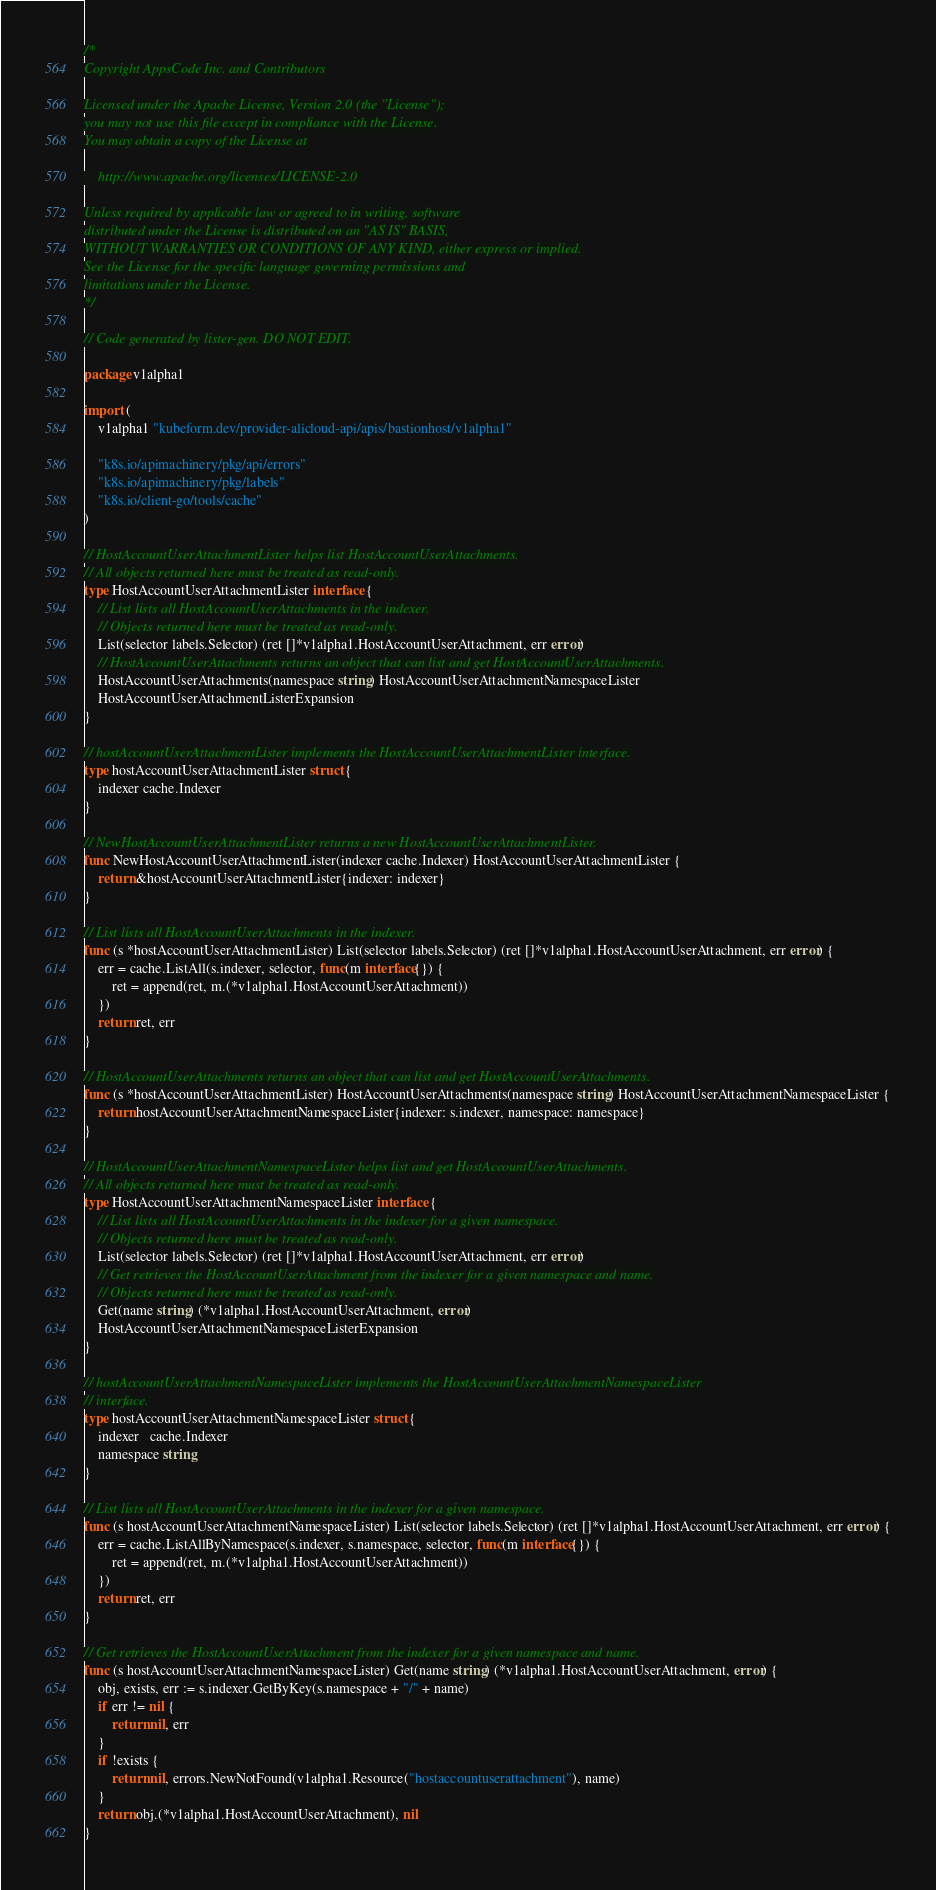Convert code to text. <code><loc_0><loc_0><loc_500><loc_500><_Go_>/*
Copyright AppsCode Inc. and Contributors

Licensed under the Apache License, Version 2.0 (the "License");
you may not use this file except in compliance with the License.
You may obtain a copy of the License at

    http://www.apache.org/licenses/LICENSE-2.0

Unless required by applicable law or agreed to in writing, software
distributed under the License is distributed on an "AS IS" BASIS,
WITHOUT WARRANTIES OR CONDITIONS OF ANY KIND, either express or implied.
See the License for the specific language governing permissions and
limitations under the License.
*/

// Code generated by lister-gen. DO NOT EDIT.

package v1alpha1

import (
	v1alpha1 "kubeform.dev/provider-alicloud-api/apis/bastionhost/v1alpha1"

	"k8s.io/apimachinery/pkg/api/errors"
	"k8s.io/apimachinery/pkg/labels"
	"k8s.io/client-go/tools/cache"
)

// HostAccountUserAttachmentLister helps list HostAccountUserAttachments.
// All objects returned here must be treated as read-only.
type HostAccountUserAttachmentLister interface {
	// List lists all HostAccountUserAttachments in the indexer.
	// Objects returned here must be treated as read-only.
	List(selector labels.Selector) (ret []*v1alpha1.HostAccountUserAttachment, err error)
	// HostAccountUserAttachments returns an object that can list and get HostAccountUserAttachments.
	HostAccountUserAttachments(namespace string) HostAccountUserAttachmentNamespaceLister
	HostAccountUserAttachmentListerExpansion
}

// hostAccountUserAttachmentLister implements the HostAccountUserAttachmentLister interface.
type hostAccountUserAttachmentLister struct {
	indexer cache.Indexer
}

// NewHostAccountUserAttachmentLister returns a new HostAccountUserAttachmentLister.
func NewHostAccountUserAttachmentLister(indexer cache.Indexer) HostAccountUserAttachmentLister {
	return &hostAccountUserAttachmentLister{indexer: indexer}
}

// List lists all HostAccountUserAttachments in the indexer.
func (s *hostAccountUserAttachmentLister) List(selector labels.Selector) (ret []*v1alpha1.HostAccountUserAttachment, err error) {
	err = cache.ListAll(s.indexer, selector, func(m interface{}) {
		ret = append(ret, m.(*v1alpha1.HostAccountUserAttachment))
	})
	return ret, err
}

// HostAccountUserAttachments returns an object that can list and get HostAccountUserAttachments.
func (s *hostAccountUserAttachmentLister) HostAccountUserAttachments(namespace string) HostAccountUserAttachmentNamespaceLister {
	return hostAccountUserAttachmentNamespaceLister{indexer: s.indexer, namespace: namespace}
}

// HostAccountUserAttachmentNamespaceLister helps list and get HostAccountUserAttachments.
// All objects returned here must be treated as read-only.
type HostAccountUserAttachmentNamespaceLister interface {
	// List lists all HostAccountUserAttachments in the indexer for a given namespace.
	// Objects returned here must be treated as read-only.
	List(selector labels.Selector) (ret []*v1alpha1.HostAccountUserAttachment, err error)
	// Get retrieves the HostAccountUserAttachment from the indexer for a given namespace and name.
	// Objects returned here must be treated as read-only.
	Get(name string) (*v1alpha1.HostAccountUserAttachment, error)
	HostAccountUserAttachmentNamespaceListerExpansion
}

// hostAccountUserAttachmentNamespaceLister implements the HostAccountUserAttachmentNamespaceLister
// interface.
type hostAccountUserAttachmentNamespaceLister struct {
	indexer   cache.Indexer
	namespace string
}

// List lists all HostAccountUserAttachments in the indexer for a given namespace.
func (s hostAccountUserAttachmentNamespaceLister) List(selector labels.Selector) (ret []*v1alpha1.HostAccountUserAttachment, err error) {
	err = cache.ListAllByNamespace(s.indexer, s.namespace, selector, func(m interface{}) {
		ret = append(ret, m.(*v1alpha1.HostAccountUserAttachment))
	})
	return ret, err
}

// Get retrieves the HostAccountUserAttachment from the indexer for a given namespace and name.
func (s hostAccountUserAttachmentNamespaceLister) Get(name string) (*v1alpha1.HostAccountUserAttachment, error) {
	obj, exists, err := s.indexer.GetByKey(s.namespace + "/" + name)
	if err != nil {
		return nil, err
	}
	if !exists {
		return nil, errors.NewNotFound(v1alpha1.Resource("hostaccountuserattachment"), name)
	}
	return obj.(*v1alpha1.HostAccountUserAttachment), nil
}
</code> 